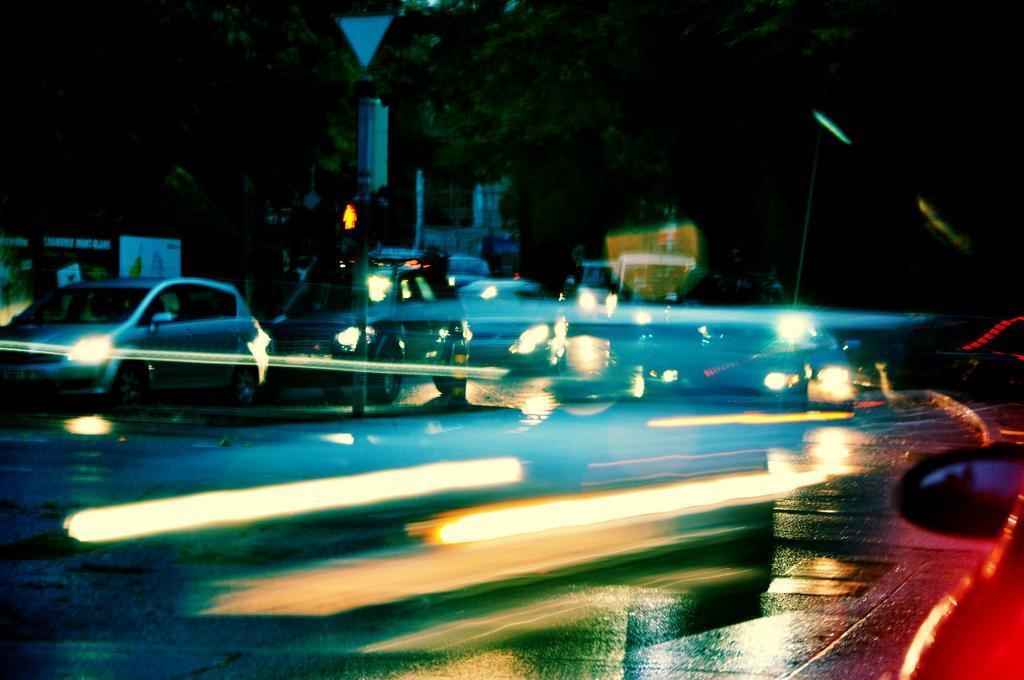In one or two sentences, can you explain what this image depicts? In this picture we can see vehicles on the road, poles, traffic signal and boards. In the background of the image we can see trees and objects. 